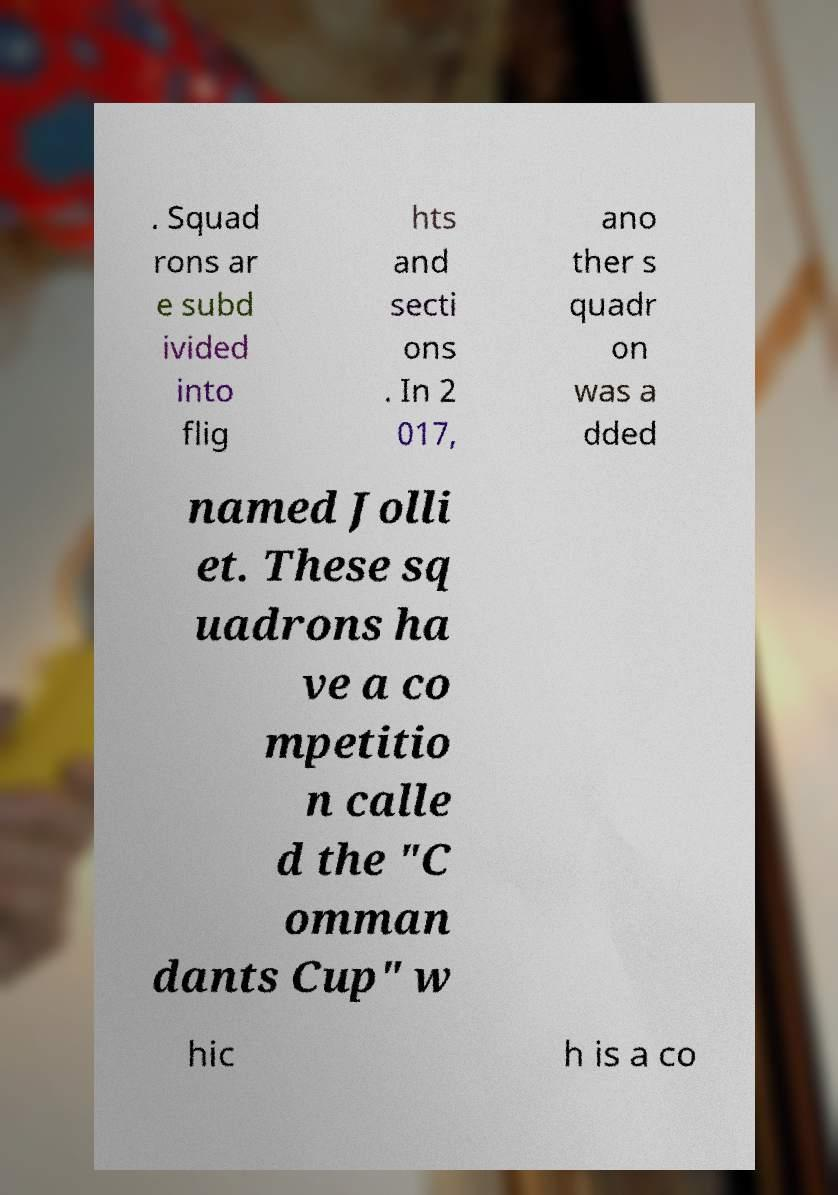Can you read and provide the text displayed in the image?This photo seems to have some interesting text. Can you extract and type it out for me? . Squad rons ar e subd ivided into flig hts and secti ons . In 2 017, ano ther s quadr on was a dded named Jolli et. These sq uadrons ha ve a co mpetitio n calle d the "C omman dants Cup" w hic h is a co 